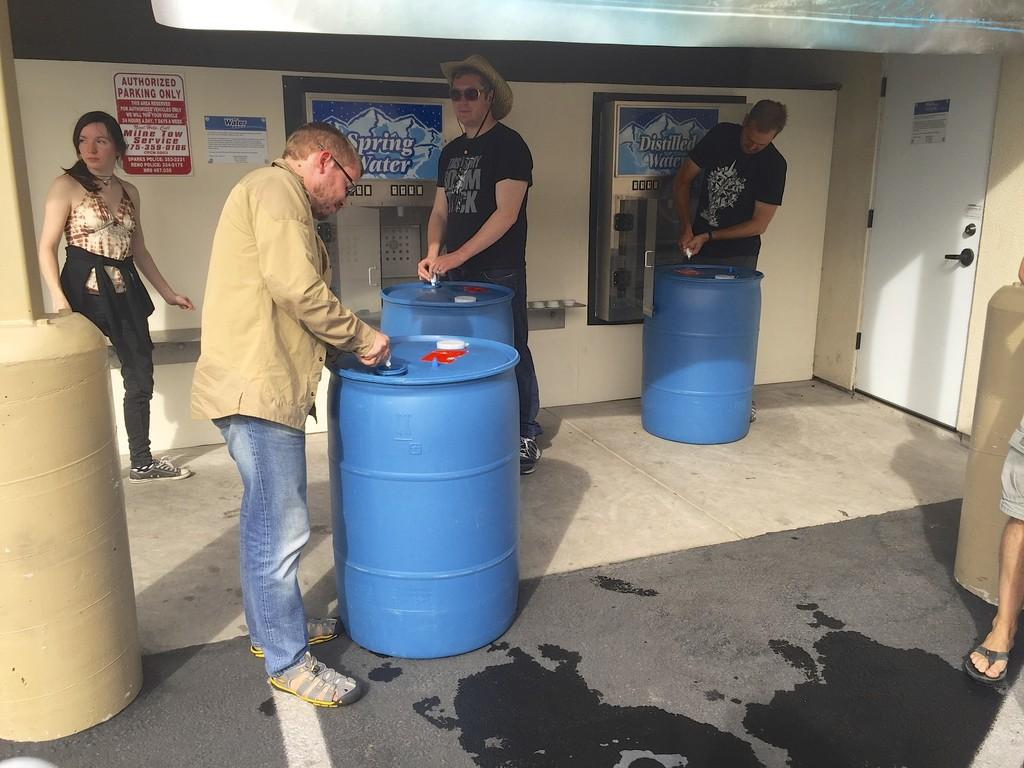Provide a one-sentence caption for the provided image. A few people are gathered around barrels in front of a spring water station. 